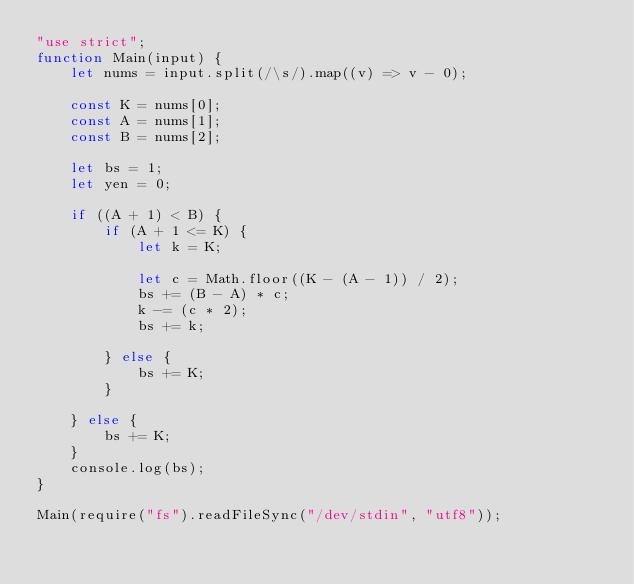Convert code to text. <code><loc_0><loc_0><loc_500><loc_500><_JavaScript_>"use strict";
function Main(input) {
    let nums = input.split(/\s/).map((v) => v - 0);

    const K = nums[0];
    const A = nums[1];
    const B = nums[2];

    let bs = 1;
    let yen = 0;
    
    if ((A + 1) < B) {
        if (A + 1 <= K) {
            let k = K;
            
            let c = Math.floor((K - (A - 1)) / 2);
            bs += (B - A) * c;
            k -= (c * 2);
            bs += k;

        } else {
            bs += K;
        }

    } else {
        bs += K;
    }
    console.log(bs);
}

Main(require("fs").readFileSync("/dev/stdin", "utf8"));
</code> 